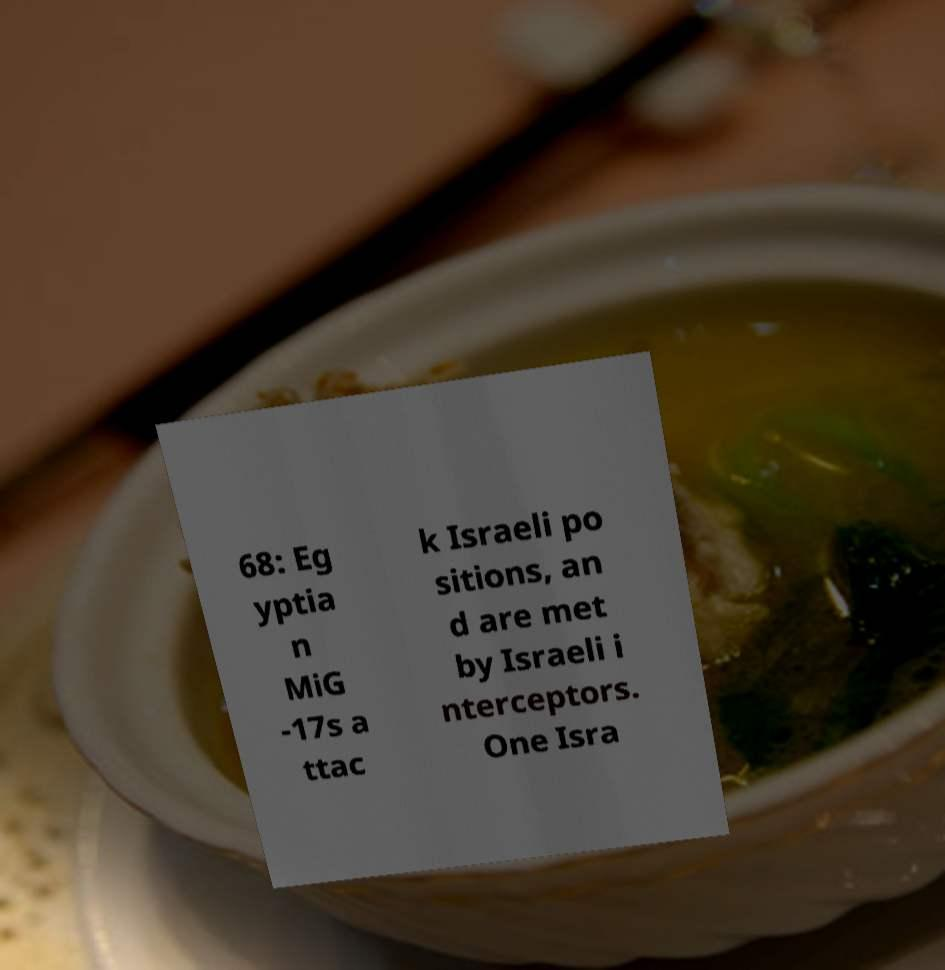What messages or text are displayed in this image? I need them in a readable, typed format. 68: Eg yptia n MiG -17s a ttac k Israeli po sitions, an d are met by Israeli i nterceptors. One Isra 